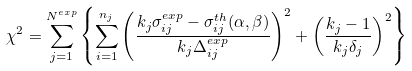Convert formula to latex. <formula><loc_0><loc_0><loc_500><loc_500>\chi ^ { 2 } = \sum _ { j = 1 } ^ { N ^ { e x p } } \left \{ \sum _ { i = 1 } ^ { n _ { j } } \left ( \frac { k _ { j } \sigma _ { i j } ^ { e x p } - \sigma _ { i j } ^ { t h } ( \alpha , \beta ) } { k _ { j } \Delta _ { i j } ^ { e x p } } \right ) ^ { 2 } + \left ( \frac { k _ { j } - 1 } { k _ { j } \delta _ { j } } \right ) ^ { 2 } \right \}</formula> 